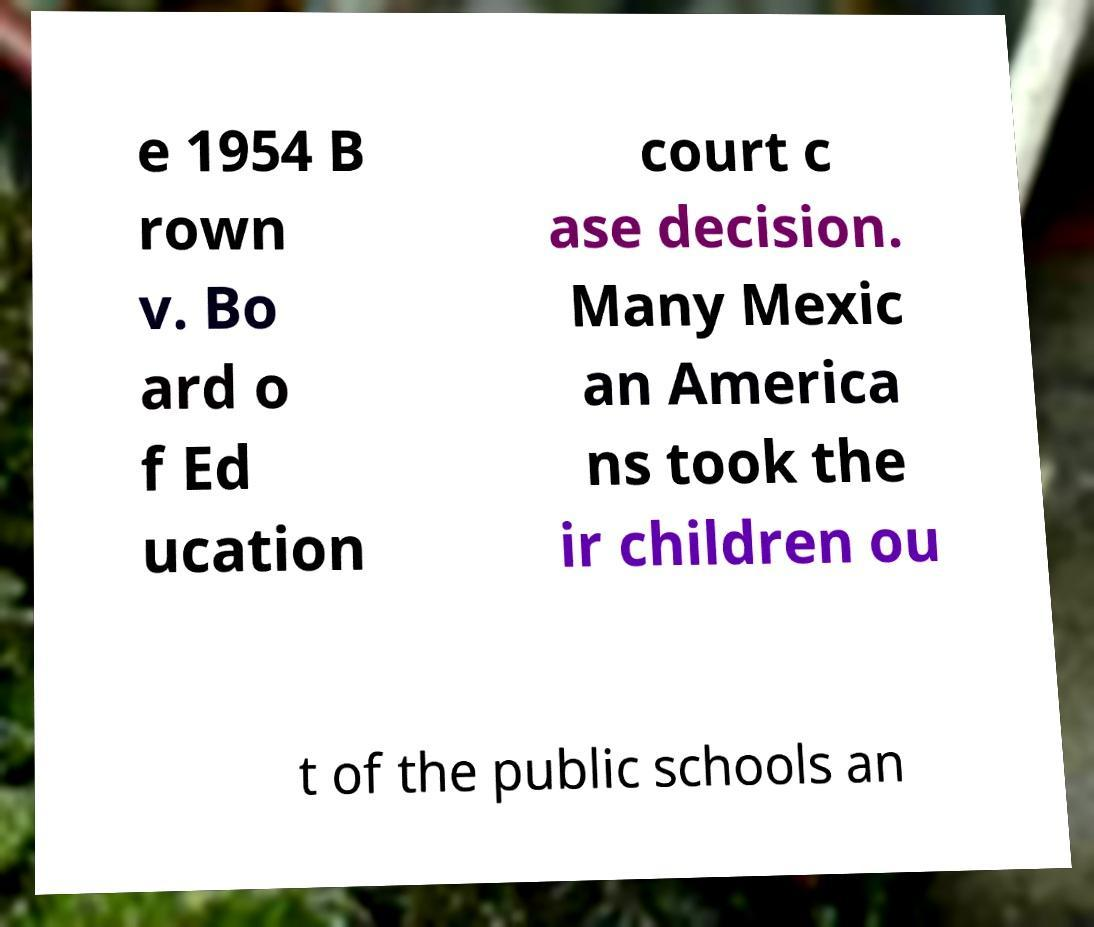Could you assist in decoding the text presented in this image and type it out clearly? e 1954 B rown v. Bo ard o f Ed ucation court c ase decision. Many Mexic an America ns took the ir children ou t of the public schools an 